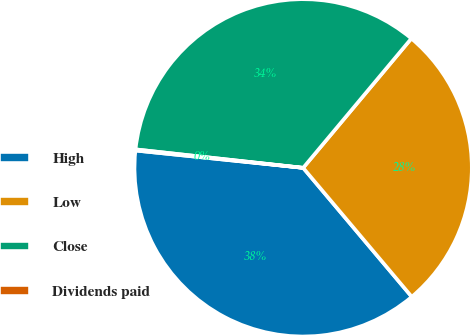<chart> <loc_0><loc_0><loc_500><loc_500><pie_chart><fcel>High<fcel>Low<fcel>Close<fcel>Dividends paid<nl><fcel>37.78%<fcel>27.77%<fcel>34.34%<fcel>0.11%<nl></chart> 